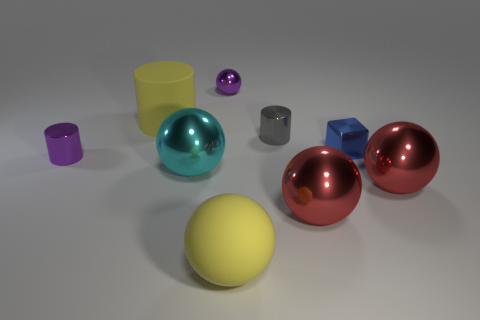Subtract 2 balls. How many balls are left? 3 Subtract all purple spheres. How many spheres are left? 4 Subtract all big rubber spheres. How many spheres are left? 4 Subtract all gray spheres. Subtract all cyan blocks. How many spheres are left? 5 Add 1 cubes. How many objects exist? 10 Subtract all cubes. How many objects are left? 8 Subtract all purple objects. Subtract all gray objects. How many objects are left? 6 Add 8 tiny gray cylinders. How many tiny gray cylinders are left? 9 Add 8 large gray metallic spheres. How many large gray metallic spheres exist? 8 Subtract 1 yellow cylinders. How many objects are left? 8 